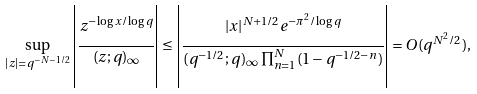<formula> <loc_0><loc_0><loc_500><loc_500>\sup _ { | z | = q ^ { - N - 1 / 2 } } \left | \cfrac { z ^ { - \log x / \log q } } { ( z ; q ) _ { \infty } } \right | \leq \left | \cfrac { | x | ^ { N + 1 / 2 } e ^ { - \pi ^ { 2 } / \log q } } { ( q ^ { - 1 / 2 } ; q ) _ { \infty } \prod _ { n = 1 } ^ { N } ( 1 - q ^ { - 1 / 2 - n } ) } \right | = O ( q ^ { N ^ { 2 } / 2 } ) ,</formula> 